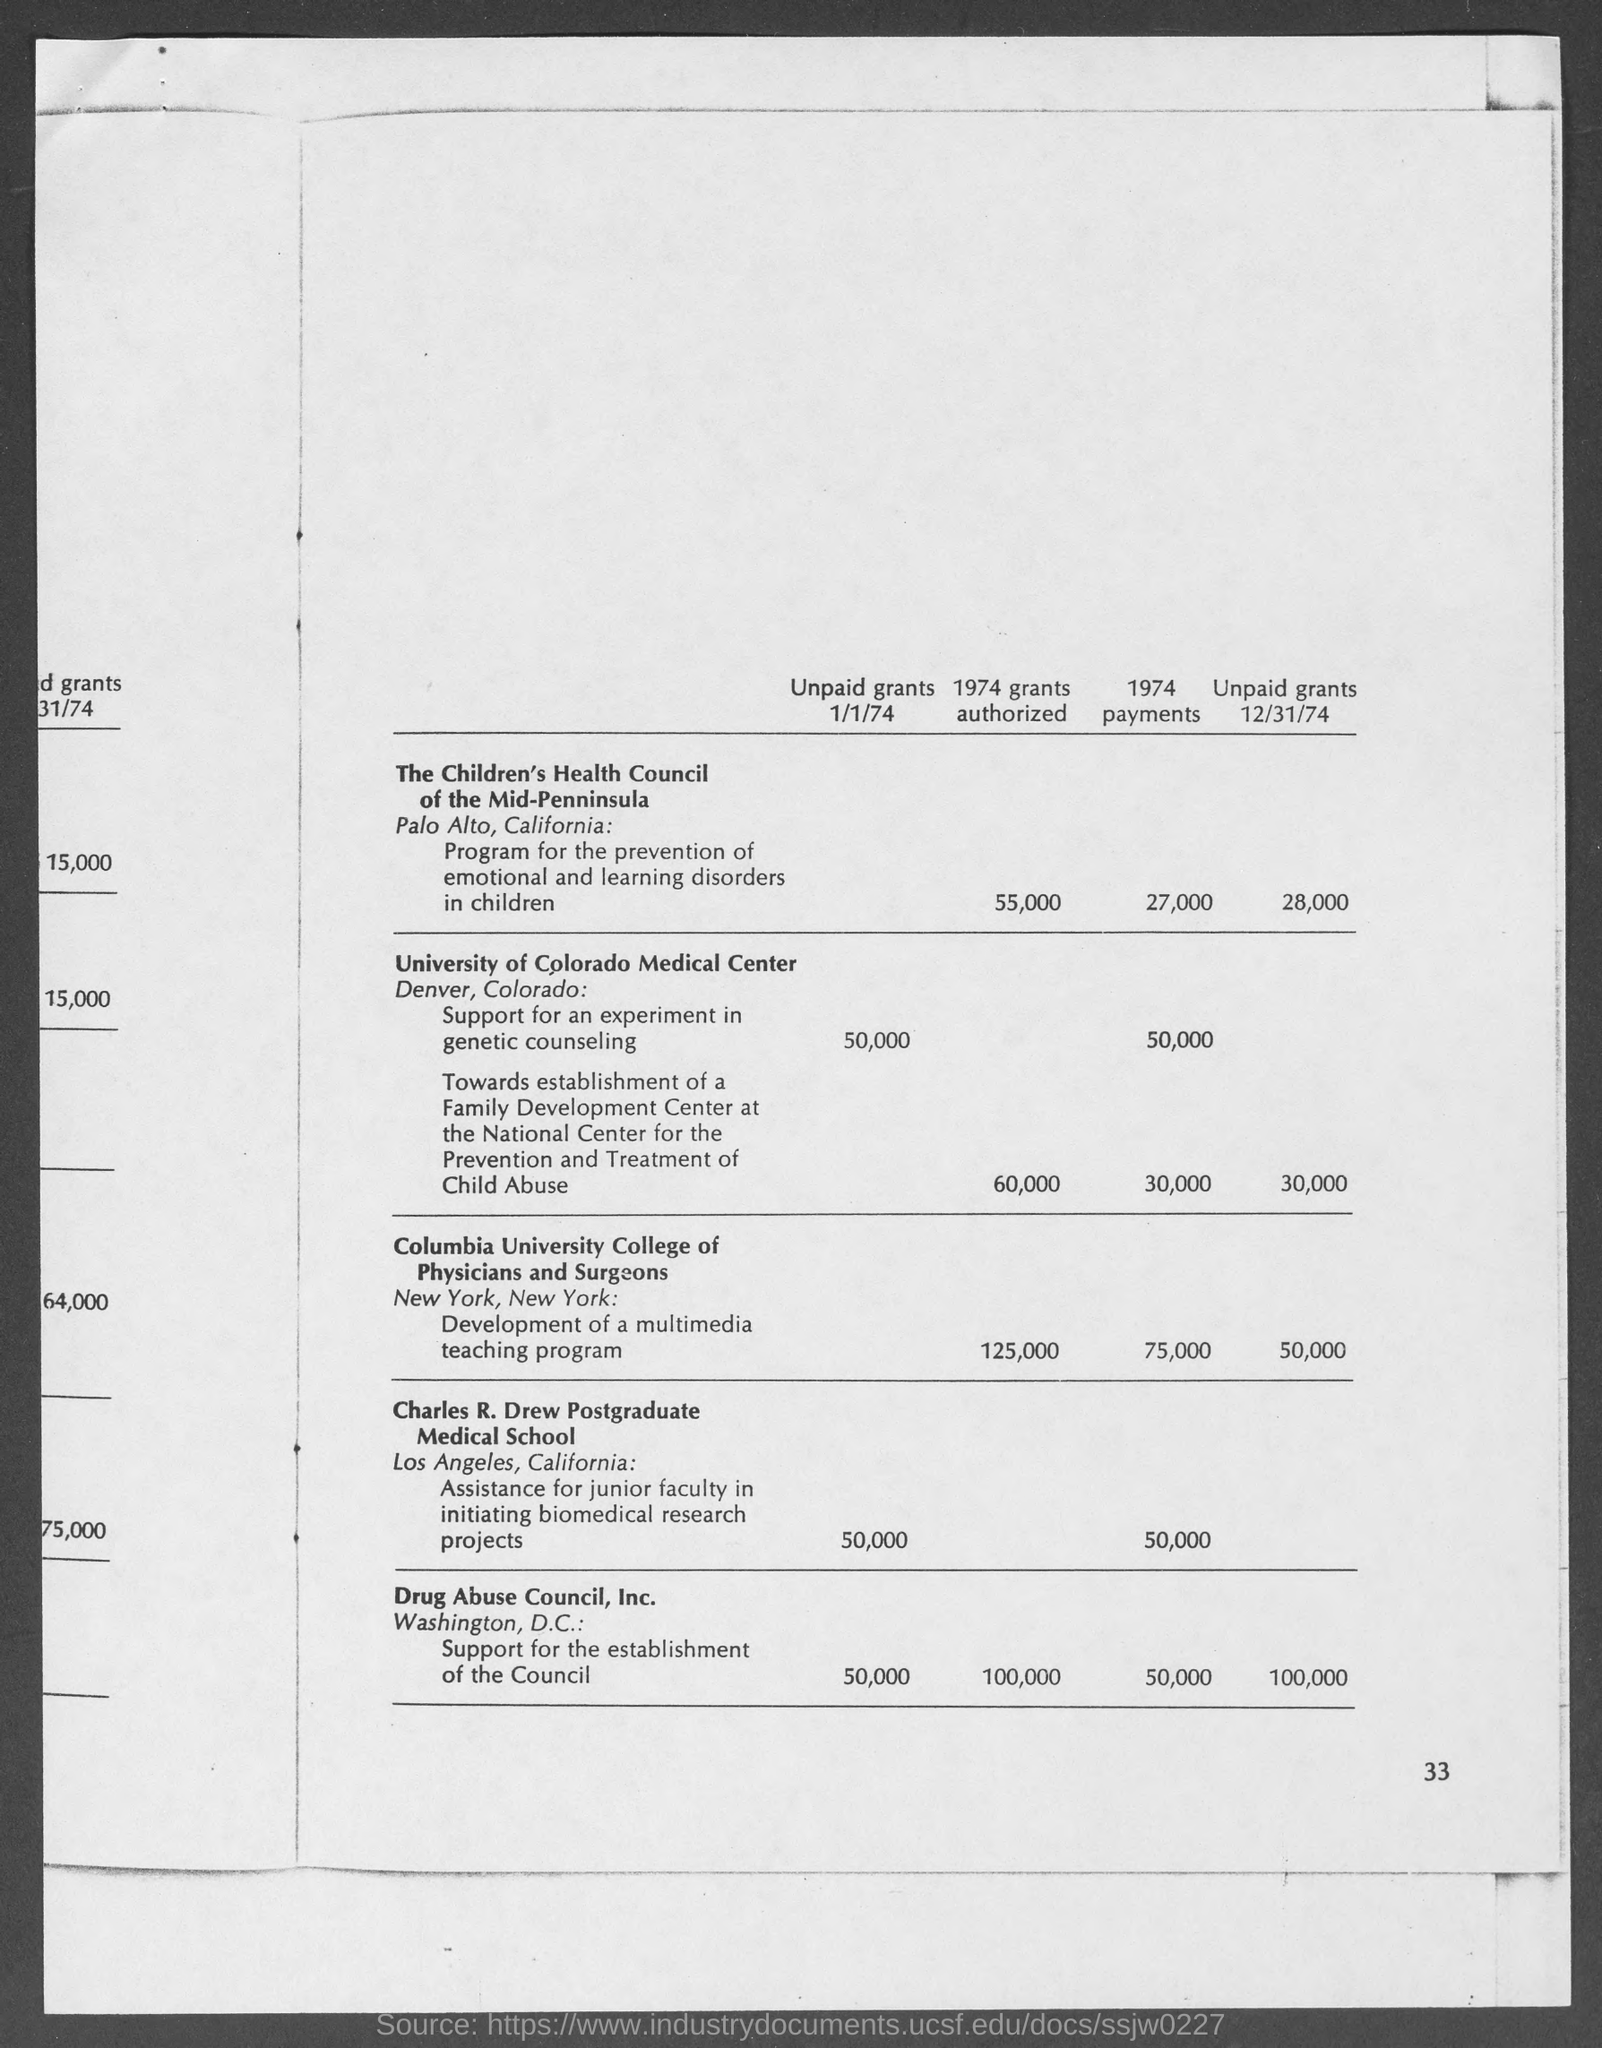What is the amount of 1974 grants authorized for the children's health council of the mid-penninsula ?
Your answer should be very brief. 55,000. What is the amount of 1974 payments for the children's health council of the mid- penninsula ?
Your answer should be very brief. 27,000. What is the amount of unpaid grants of 12/31/74 for the children's health council of the mid - penninsula ?
Your response must be concise. 28,000. What is the amount of unpaid grants 1/1/74 for the university of colorado medical center ?
Provide a succinct answer. 50,000. 